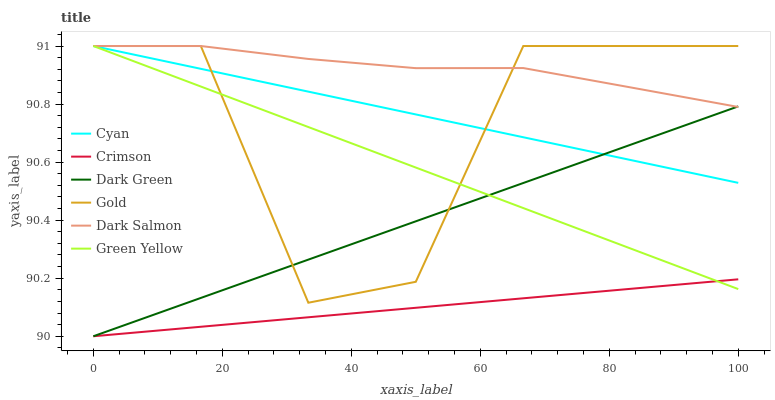Does Crimson have the minimum area under the curve?
Answer yes or no. Yes. Does Dark Salmon have the maximum area under the curve?
Answer yes or no. Yes. Does Dark Salmon have the minimum area under the curve?
Answer yes or no. No. Does Crimson have the maximum area under the curve?
Answer yes or no. No. Is Crimson the smoothest?
Answer yes or no. Yes. Is Gold the roughest?
Answer yes or no. Yes. Is Dark Salmon the smoothest?
Answer yes or no. No. Is Dark Salmon the roughest?
Answer yes or no. No. Does Crimson have the lowest value?
Answer yes or no. Yes. Does Dark Salmon have the lowest value?
Answer yes or no. No. Does Green Yellow have the highest value?
Answer yes or no. Yes. Does Crimson have the highest value?
Answer yes or no. No. Is Crimson less than Cyan?
Answer yes or no. Yes. Is Gold greater than Crimson?
Answer yes or no. Yes. Does Crimson intersect Dark Green?
Answer yes or no. Yes. Is Crimson less than Dark Green?
Answer yes or no. No. Is Crimson greater than Dark Green?
Answer yes or no. No. Does Crimson intersect Cyan?
Answer yes or no. No. 